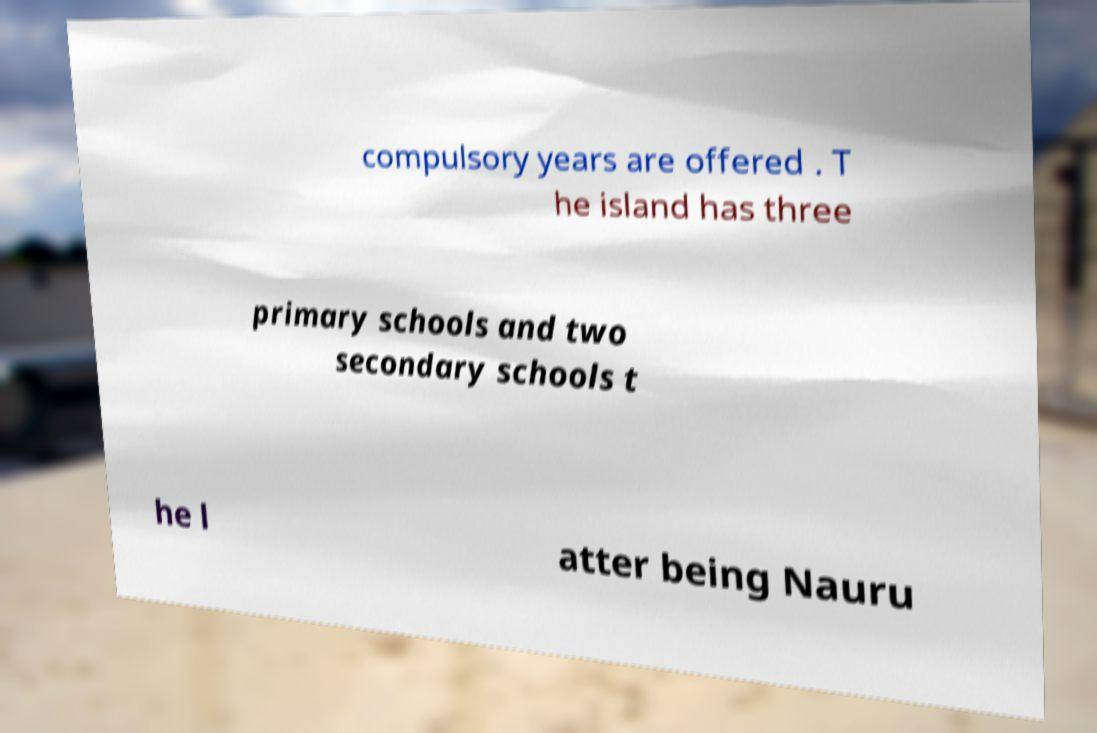There's text embedded in this image that I need extracted. Can you transcribe it verbatim? compulsory years are offered . T he island has three primary schools and two secondary schools t he l atter being Nauru 